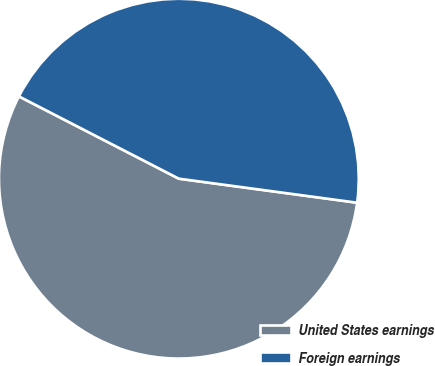Convert chart to OTSL. <chart><loc_0><loc_0><loc_500><loc_500><pie_chart><fcel>United States earnings<fcel>Foreign earnings<nl><fcel>55.43%<fcel>44.57%<nl></chart> 